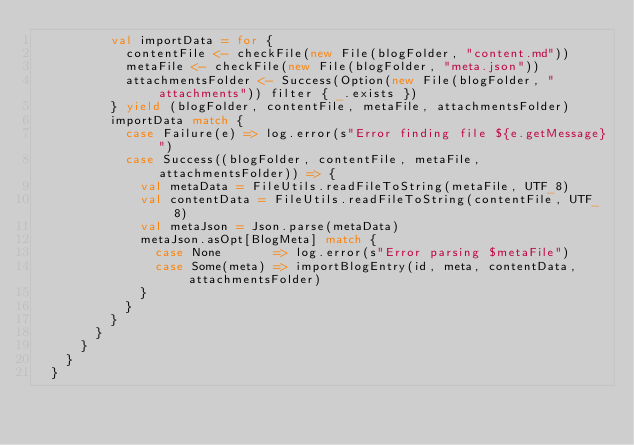Convert code to text. <code><loc_0><loc_0><loc_500><loc_500><_Scala_>          val importData = for {
            contentFile <- checkFile(new File(blogFolder, "content.md"))
            metaFile <- checkFile(new File(blogFolder, "meta.json"))
            attachmentsFolder <- Success(Option(new File(blogFolder, "attachments")) filter { _.exists })
          } yield (blogFolder, contentFile, metaFile, attachmentsFolder)
          importData match {
            case Failure(e) => log.error(s"Error finding file ${e.getMessage}")
            case Success((blogFolder, contentFile, metaFile, attachmentsFolder)) => {
              val metaData = FileUtils.readFileToString(metaFile, UTF_8)
              val contentData = FileUtils.readFileToString(contentFile, UTF_8)
              val metaJson = Json.parse(metaData)
              metaJson.asOpt[BlogMeta] match {
                case None       => log.error(s"Error parsing $metaFile")
                case Some(meta) => importBlogEntry(id, meta, contentData, attachmentsFolder)
              }
            }
          }
        }
      }
    }
  }
</code> 